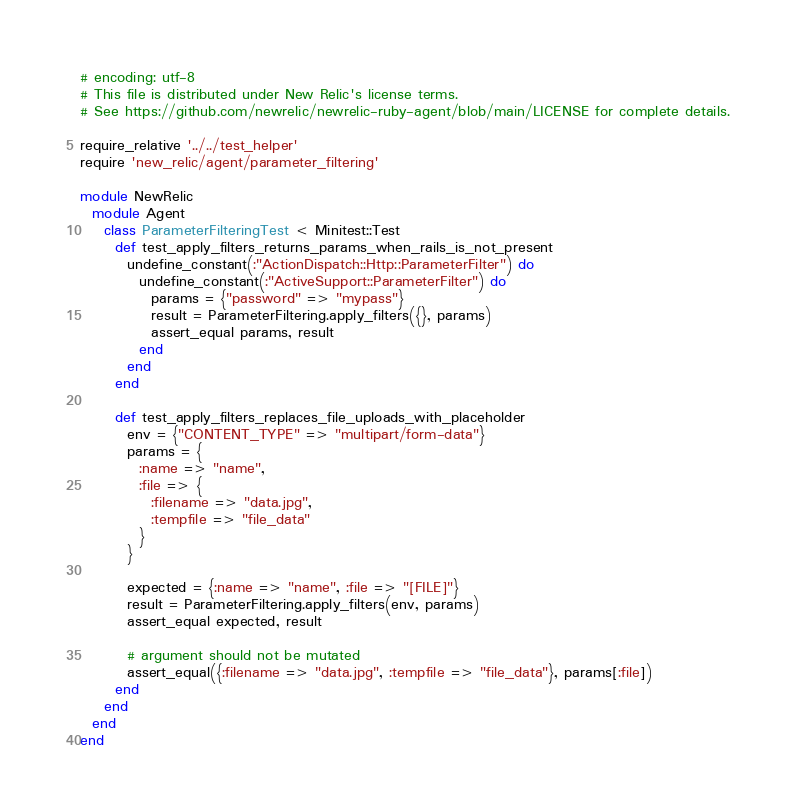Convert code to text. <code><loc_0><loc_0><loc_500><loc_500><_Ruby_># encoding: utf-8
# This file is distributed under New Relic's license terms.
# See https://github.com/newrelic/newrelic-ruby-agent/blob/main/LICENSE for complete details.

require_relative '../../test_helper'
require 'new_relic/agent/parameter_filtering'

module NewRelic
  module Agent
    class ParameterFilteringTest < Minitest::Test
      def test_apply_filters_returns_params_when_rails_is_not_present
        undefine_constant(:"ActionDispatch::Http::ParameterFilter") do
          undefine_constant(:"ActiveSupport::ParameterFilter") do
            params = {"password" => "mypass"}
            result = ParameterFiltering.apply_filters({}, params)
            assert_equal params, result
          end
        end
      end

      def test_apply_filters_replaces_file_uploads_with_placeholder
        env = {"CONTENT_TYPE" => "multipart/form-data"}
        params = {
          :name => "name",
          :file => {
            :filename => "data.jpg",
            :tempfile => "file_data"
          }
        }

        expected = {:name => "name", :file => "[FILE]"}
        result = ParameterFiltering.apply_filters(env, params)
        assert_equal expected, result

        # argument should not be mutated
        assert_equal({:filename => "data.jpg", :tempfile => "file_data"}, params[:file])
      end
    end
  end
end
</code> 